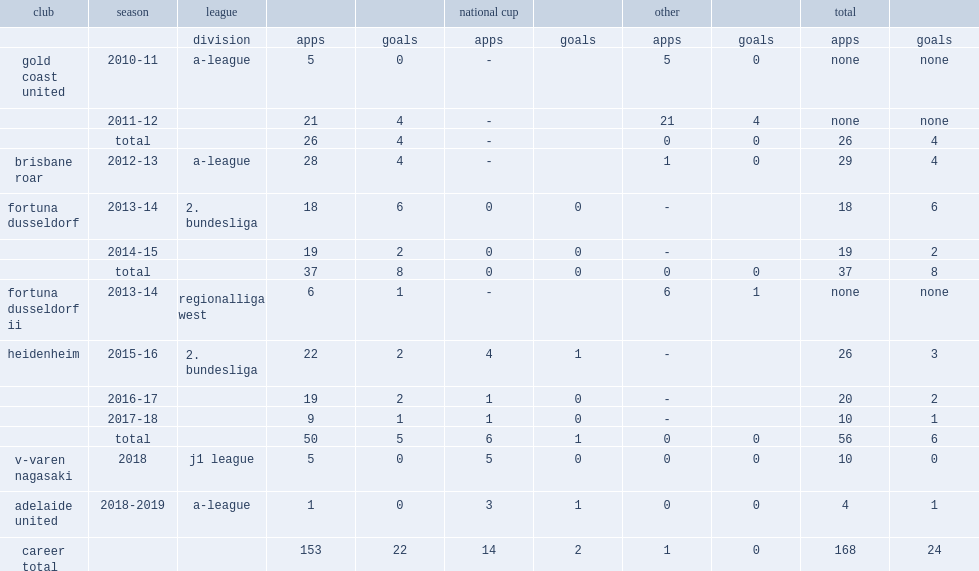Which club did halloran play for in 2012-13? Brisbane roar. Parse the full table. {'header': ['club', 'season', 'league', '', '', 'national cup', '', 'other', '', 'total', ''], 'rows': [['', '', 'division', 'apps', 'goals', 'apps', 'goals', 'apps', 'goals', 'apps', 'goals'], ['gold coast united', '2010-11', 'a-league', '5', '0', '-', '', '5', '0', 'none', 'none'], ['', '2011-12', '', '21', '4', '-', '', '21', '4', 'none', 'none'], ['', 'total', '', '26', '4', '-', '', '0', '0', '26', '4'], ['brisbane roar', '2012-13', 'a-league', '28', '4', '-', '', '1', '0', '29', '4'], ['fortuna dusseldorf', '2013-14', '2. bundesliga', '18', '6', '0', '0', '-', '', '18', '6'], ['', '2014-15', '', '19', '2', '0', '0', '-', '', '19', '2'], ['', 'total', '', '37', '8', '0', '0', '0', '0', '37', '8'], ['fortuna dusseldorf ii', '2013-14', 'regionalliga west', '6', '1', '-', '', '6', '1', 'none', 'none'], ['heidenheim', '2015-16', '2. bundesliga', '22', '2', '4', '1', '-', '', '26', '3'], ['', '2016-17', '', '19', '2', '1', '0', '-', '', '20', '2'], ['', '2017-18', '', '9', '1', '1', '0', '-', '', '10', '1'], ['', 'total', '', '50', '5', '6', '1', '0', '0', '56', '6'], ['v-varen nagasaki', '2018', 'j1 league', '5', '0', '5', '0', '0', '0', '10', '0'], ['adelaide united', '2018-2019', 'a-league', '1', '0', '3', '1', '0', '0', '4', '1'], ['career total', '', '', '153', '22', '14', '2', '1', '0', '168', '24']]} 